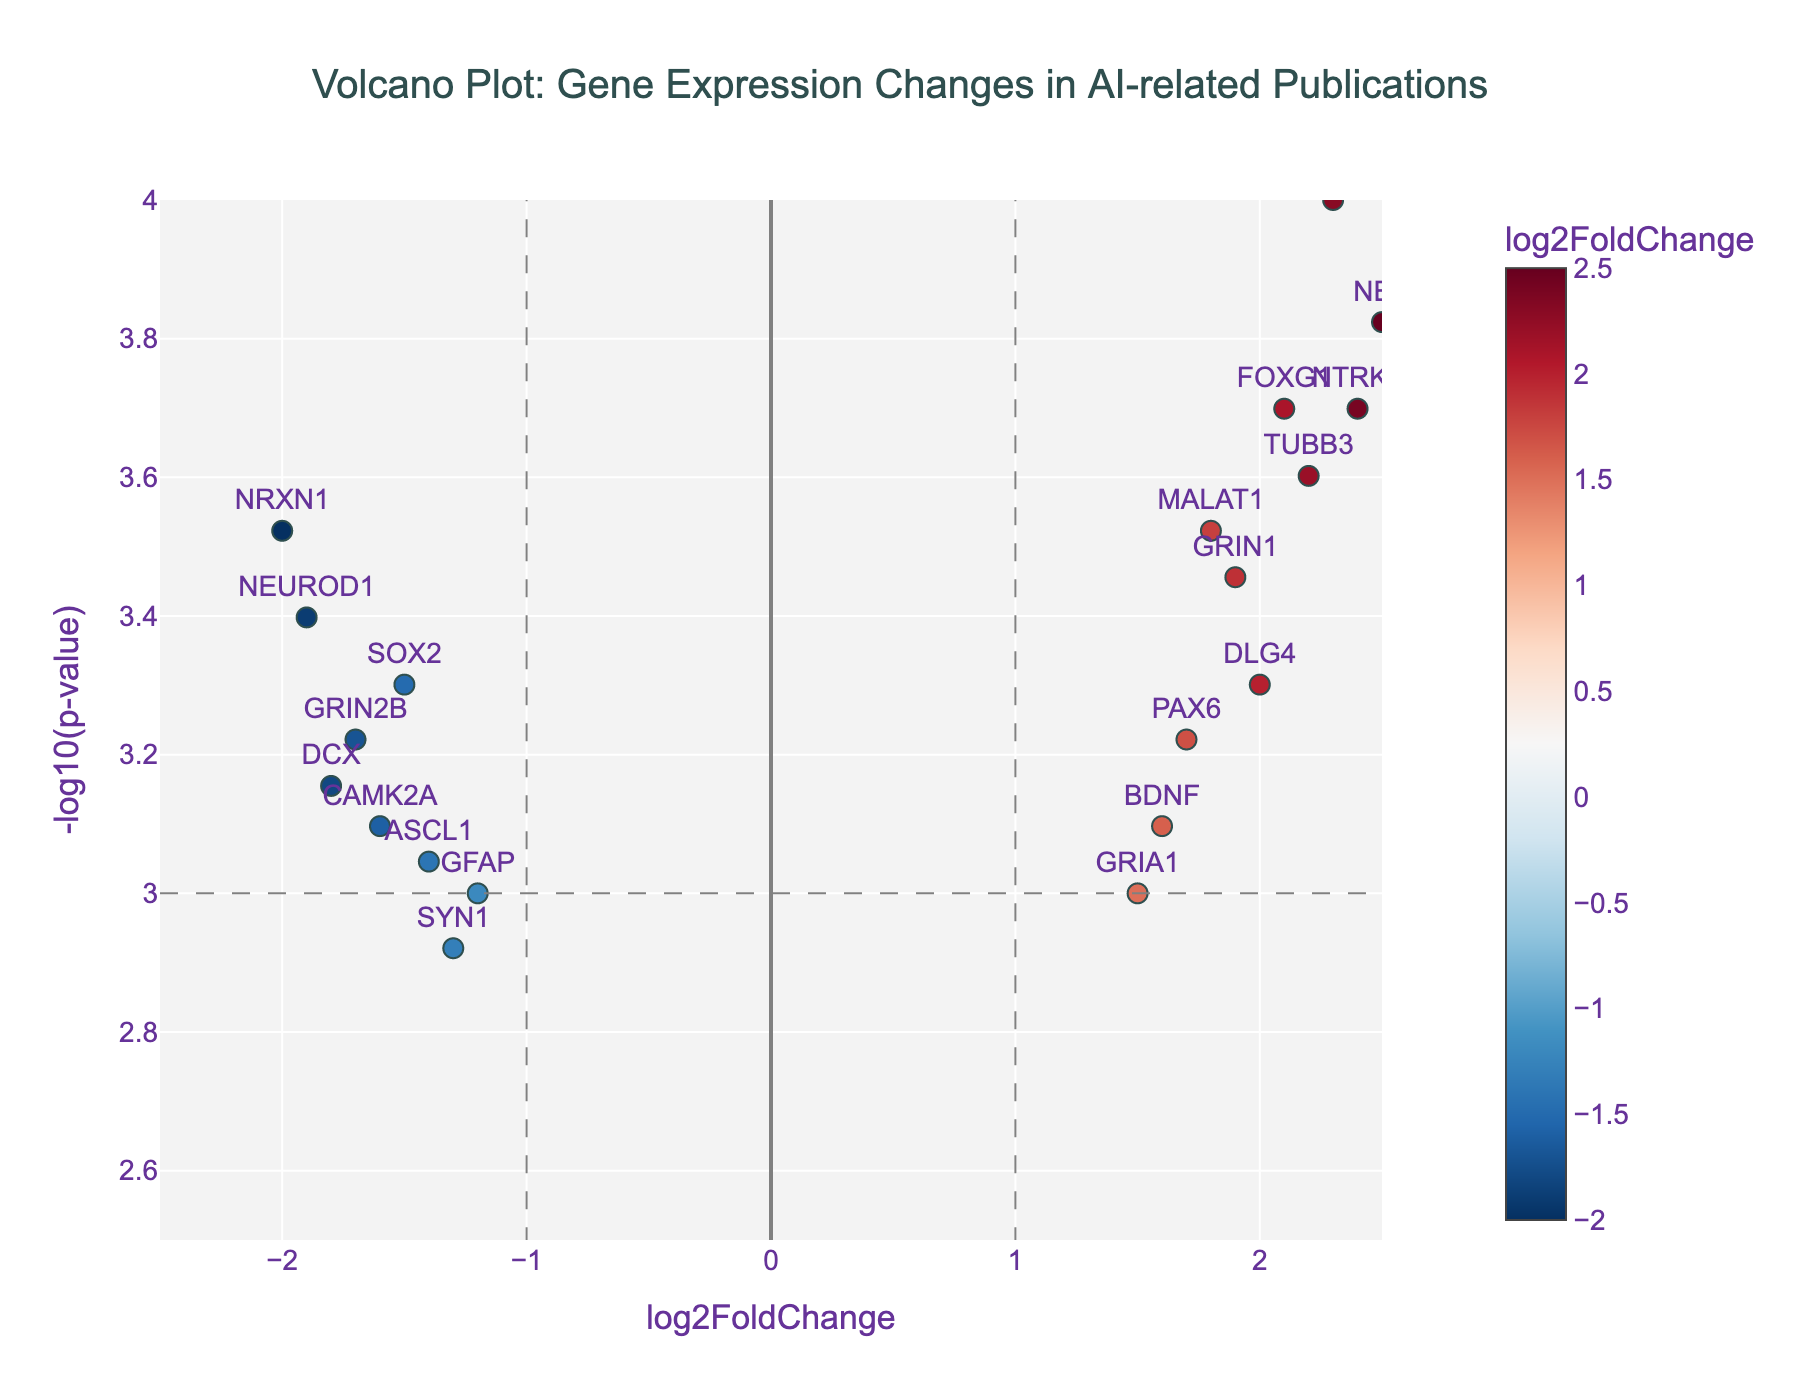What is the title of the plot? The title of the plot is shown at the top and reads "Volcano Plot: Gene Expression Changes in AI-related Publications".
Answer: Volcano Plot: Gene Expression Changes in AI-related Publications What are the x-axis and y-axis labels? The x-axis is labeled "log2FoldChange" and the y-axis is labeled "-log10(p-value)", indicating the measurements are fold changes and p-values.
Answer: log2FoldChange, -log10(p-value) Which gene has the highest log2 fold change? To find the gene with the highest log2 fold change, we look at the data points furthest to the right on the x-axis. The gene NES has the highest log2 fold change of 2.5.
Answer: NES Which gene has the lowest p-value? The gene with the lowest p-value will have the highest -log10(p-value) value. NEAT1 has the highest -log10(p-value) at around 4, making it the gene with the lowest p-value.
Answer: NEAT1 How many genes are significantly upregulated (log2FC > 1, p-value < 0.001)? To determine the number of significantly upregulated genes, we count the data points that are to the right of the x=1 line and above the horizontal line at -log10(p-value) = 3. There are 6 such genes: NEAT1, FOXG1, NES, TUBB3, DLG4, and NTRK2.
Answer: 6 How many genes are significantly downregulated (log2FC < -1, p-value < 0.001)? For downregulated genes, we count the data points to the left of the x=-1 line and above the horizontal line at -log10(p-value) = 3. There are 5 such genes: SOX2, NEUROD1, DCX, GRIN2B, and NRXN1.
Answer: 5 Which gene with a log2 fold change greater than 2 has the lowest p-value? We look for genes with log2 fold changes > 2 and find the one with the highest -log10(p-value). NES has a log2 fold change of 2.5 and a -log10(p-value) of around 4, making it the gene with the lowest p-value in this category.
Answer: NES Which gene has a log2 fold change of approximately -1.5 and what is its -log10(p-value)? The gene SOX2 has a log2 fold change of -1.5. From the figure, its -log10(p-value) is around 3.3.
Answer: SOX2, ~3.3 